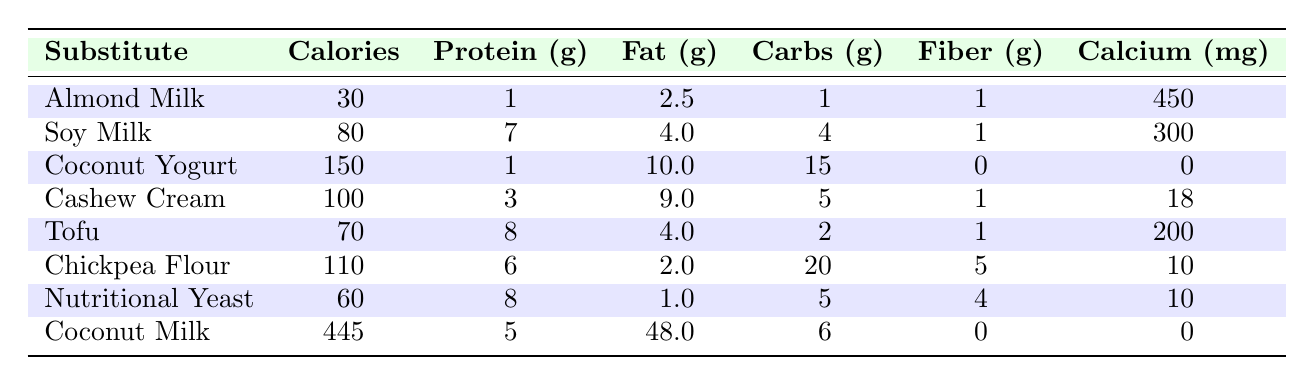What is the protein content of Tofu? The table shows that Tofu has a protein content of 8 grams.
Answer: 8 grams Which substitute has the highest fat content? By comparing the Fat column, Coconut Milk has the highest fat content with 48 grams.
Answer: Coconut Milk What is the average calorie content of the vegan substitutes listed? The total calories are 30 + 80 + 150 + 100 + 70 + 110 + 60 + 445 = 1,045. There are 8 substitutes, so the average is 1,045/8 = 130.625.
Answer: 130.625 Does Nutritional Yeast have more carbohydrates than Almond Milk? Nutritional Yeast has 5 grams of carbohydrates and Almond Milk has 1 gram. Therefore, Nutritional Yeast has more carbohydrates than Almond Milk.
Answer: Yes If you compare fiber content, which has more: Chickpea Flour or Coconut Yogurt? Chickpea Flour contains 5 grams of fiber and Coconut Yogurt contains 0 grams. Since 5 is greater than 0, Chickpea Flour has more fiber than Coconut Yogurt.
Answer: Chickpea Flour What is the total calcium content of Almond Milk and Soy Milk combined? Almond Milk has 450 mg of calcium, and Soy Milk has 300 mg. Adding them gives 450 + 300 = 750 mg.
Answer: 750 mg Is the calorie content of Coconut Yogurt greater than that of Cashew Cream? Coconut Yogurt has 150 calories while Cashew Cream has 100 calories. Since 150 is greater than 100, Coconut Yogurt has more calories.
Answer: Yes How much more protein does Soy Milk have compared to Almond Milk? Soy Milk has 7 grams of protein and Almond Milk has 1 gram. The difference is 7 - 1 = 6 grams.
Answer: 6 grams 